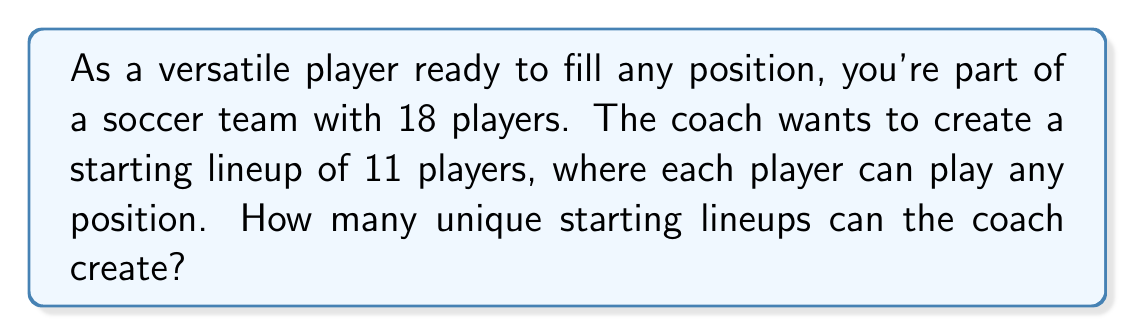Can you answer this question? To solve this problem, we need to use the combination formula. Here's why:

1. The order doesn't matter (it's not about specific positions, just who's on the field).
2. We're selecting 11 players from a pool of 18.
3. Each player can only be selected once.

The combination formula for selecting $r$ items from $n$ items is:

$$ C(n,r) = \frac{n!}{r!(n-r)!} $$

In this case:
$n = 18$ (total number of players)
$r = 11$ (number of players in the starting lineup)

Let's substitute these values:

$$ C(18,11) = \frac{18!}{11!(18-11)!} = \frac{18!}{11!7!} $$

Now, let's calculate this step-by-step:

1) $18! = 6.4023737 \times 10^{15}$
2) $11! = 39,916,800$
3) $7! = 5,040$

Substituting these values:

$$ \frac{6.4023737 \times 10^{15}}{39,916,800 \times 5,040} = 31,824 $$

Therefore, the coach can create 31,824 unique starting lineups.
Answer: 31,824 unique starting lineups 